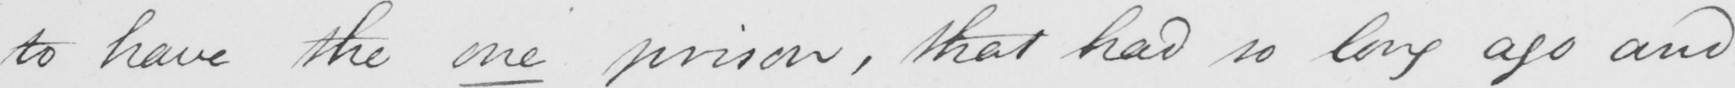Can you tell me what this handwritten text says? to have the one prison , that had so long ago and 